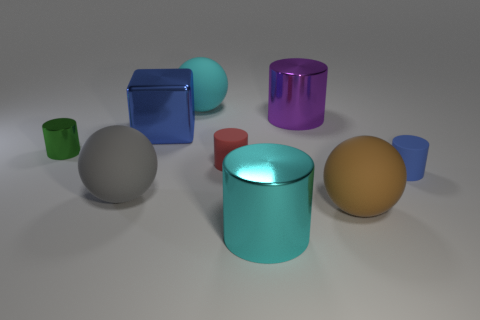Imagine these objects are part of a game. What could be the rules? If these objects were part of a game, one could imagine a rule set focusing on memory and tactile sensation. Players might close their eyes, feel an object, then have to recall its color and shape, or match it with similar objects from a mixed bag. What skills would such a game enhance? This game could enhance a variety of skills, including memory, sensory perception, and the ability to identify and differentiate objects based on subtle tactile cues. 